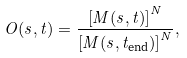Convert formula to latex. <formula><loc_0><loc_0><loc_500><loc_500>O ( s , t ) = \frac { \left [ M ( s , t ) \right ] ^ { N } } { \left [ M ( s , t _ { \text {end} } ) \right ] ^ { N } } ,</formula> 